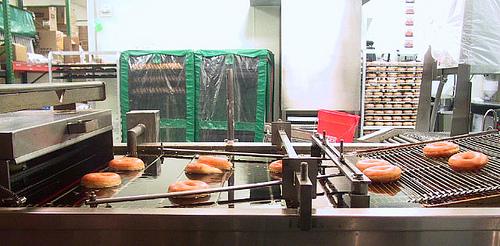Is there a lot of grease on these donuts?
Be succinct. Yes. What are the donuts being dropped into?
Answer briefly. Oven. What is being cooked?
Short answer required. Donuts. Are these donuts hot?
Keep it brief. Yes. 